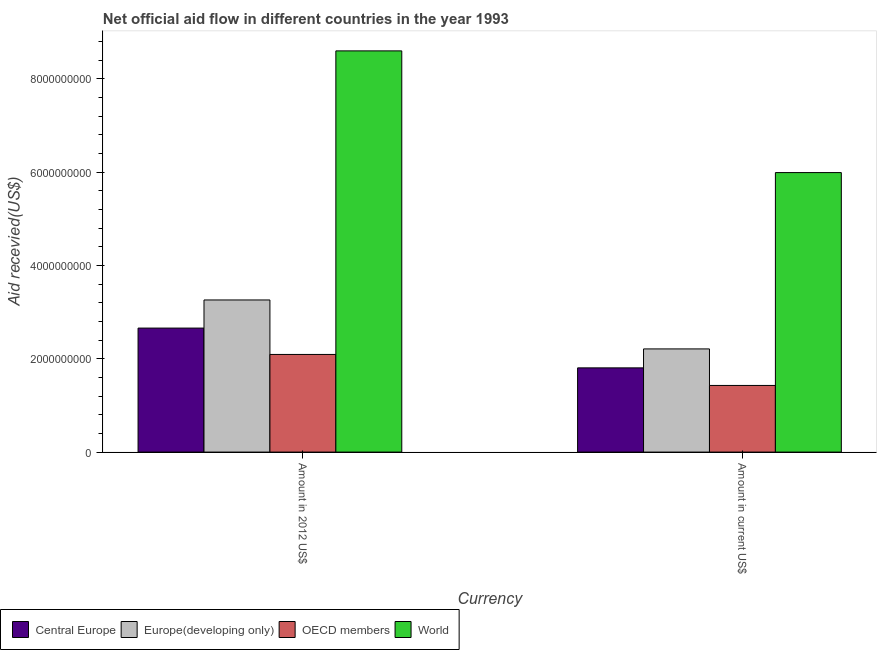How many different coloured bars are there?
Your response must be concise. 4. How many groups of bars are there?
Provide a short and direct response. 2. Are the number of bars on each tick of the X-axis equal?
Provide a short and direct response. Yes. How many bars are there on the 1st tick from the right?
Provide a short and direct response. 4. What is the label of the 2nd group of bars from the left?
Ensure brevity in your answer.  Amount in current US$. What is the amount of aid received(expressed in us$) in OECD members?
Offer a terse response. 1.43e+09. Across all countries, what is the maximum amount of aid received(expressed in 2012 us$)?
Ensure brevity in your answer.  8.60e+09. Across all countries, what is the minimum amount of aid received(expressed in 2012 us$)?
Keep it short and to the point. 2.09e+09. In which country was the amount of aid received(expressed in us$) maximum?
Make the answer very short. World. In which country was the amount of aid received(expressed in 2012 us$) minimum?
Keep it short and to the point. OECD members. What is the total amount of aid received(expressed in us$) in the graph?
Make the answer very short. 1.14e+1. What is the difference between the amount of aid received(expressed in us$) in OECD members and that in Europe(developing only)?
Offer a very short reply. -7.83e+08. What is the difference between the amount of aid received(expressed in us$) in Central Europe and the amount of aid received(expressed in 2012 us$) in World?
Your answer should be compact. -6.79e+09. What is the average amount of aid received(expressed in us$) per country?
Ensure brevity in your answer.  2.86e+09. What is the difference between the amount of aid received(expressed in 2012 us$) and amount of aid received(expressed in us$) in Central Europe?
Offer a terse response. 8.53e+08. What is the ratio of the amount of aid received(expressed in 2012 us$) in OECD members to that in Central Europe?
Make the answer very short. 0.79. What does the 1st bar from the right in Amount in 2012 US$ represents?
Your answer should be very brief. World. How many countries are there in the graph?
Offer a terse response. 4. What is the difference between two consecutive major ticks on the Y-axis?
Your response must be concise. 2.00e+09. Are the values on the major ticks of Y-axis written in scientific E-notation?
Keep it short and to the point. No. How many legend labels are there?
Make the answer very short. 4. How are the legend labels stacked?
Keep it short and to the point. Horizontal. What is the title of the graph?
Your response must be concise. Net official aid flow in different countries in the year 1993. What is the label or title of the X-axis?
Give a very brief answer. Currency. What is the label or title of the Y-axis?
Keep it short and to the point. Aid recevied(US$). What is the Aid recevied(US$) of Central Europe in Amount in 2012 US$?
Offer a terse response. 2.66e+09. What is the Aid recevied(US$) of Europe(developing only) in Amount in 2012 US$?
Provide a short and direct response. 3.26e+09. What is the Aid recevied(US$) in OECD members in Amount in 2012 US$?
Make the answer very short. 2.09e+09. What is the Aid recevied(US$) of World in Amount in 2012 US$?
Keep it short and to the point. 8.60e+09. What is the Aid recevied(US$) of Central Europe in Amount in current US$?
Make the answer very short. 1.80e+09. What is the Aid recevied(US$) in Europe(developing only) in Amount in current US$?
Your answer should be very brief. 2.21e+09. What is the Aid recevied(US$) of OECD members in Amount in current US$?
Your answer should be very brief. 1.43e+09. What is the Aid recevied(US$) in World in Amount in current US$?
Your answer should be compact. 5.99e+09. Across all Currency, what is the maximum Aid recevied(US$) in Central Europe?
Offer a very short reply. 2.66e+09. Across all Currency, what is the maximum Aid recevied(US$) in Europe(developing only)?
Give a very brief answer. 3.26e+09. Across all Currency, what is the maximum Aid recevied(US$) of OECD members?
Offer a terse response. 2.09e+09. Across all Currency, what is the maximum Aid recevied(US$) in World?
Ensure brevity in your answer.  8.60e+09. Across all Currency, what is the minimum Aid recevied(US$) in Central Europe?
Provide a short and direct response. 1.80e+09. Across all Currency, what is the minimum Aid recevied(US$) of Europe(developing only)?
Ensure brevity in your answer.  2.21e+09. Across all Currency, what is the minimum Aid recevied(US$) of OECD members?
Give a very brief answer. 1.43e+09. Across all Currency, what is the minimum Aid recevied(US$) of World?
Ensure brevity in your answer.  5.99e+09. What is the total Aid recevied(US$) in Central Europe in the graph?
Provide a succinct answer. 4.46e+09. What is the total Aid recevied(US$) of Europe(developing only) in the graph?
Offer a terse response. 5.47e+09. What is the total Aid recevied(US$) of OECD members in the graph?
Offer a terse response. 3.52e+09. What is the total Aid recevied(US$) of World in the graph?
Your answer should be compact. 1.46e+1. What is the difference between the Aid recevied(US$) of Central Europe in Amount in 2012 US$ and that in Amount in current US$?
Provide a short and direct response. 8.53e+08. What is the difference between the Aid recevied(US$) in Europe(developing only) in Amount in 2012 US$ and that in Amount in current US$?
Provide a succinct answer. 1.05e+09. What is the difference between the Aid recevied(US$) of OECD members in Amount in 2012 US$ and that in Amount in current US$?
Offer a terse response. 6.65e+08. What is the difference between the Aid recevied(US$) of World in Amount in 2012 US$ and that in Amount in current US$?
Offer a terse response. 2.61e+09. What is the difference between the Aid recevied(US$) of Central Europe in Amount in 2012 US$ and the Aid recevied(US$) of Europe(developing only) in Amount in current US$?
Give a very brief answer. 4.46e+08. What is the difference between the Aid recevied(US$) of Central Europe in Amount in 2012 US$ and the Aid recevied(US$) of OECD members in Amount in current US$?
Your answer should be compact. 1.23e+09. What is the difference between the Aid recevied(US$) in Central Europe in Amount in 2012 US$ and the Aid recevied(US$) in World in Amount in current US$?
Keep it short and to the point. -3.33e+09. What is the difference between the Aid recevied(US$) of Europe(developing only) in Amount in 2012 US$ and the Aid recevied(US$) of OECD members in Amount in current US$?
Your answer should be compact. 1.83e+09. What is the difference between the Aid recevied(US$) in Europe(developing only) in Amount in 2012 US$ and the Aid recevied(US$) in World in Amount in current US$?
Provide a succinct answer. -2.73e+09. What is the difference between the Aid recevied(US$) of OECD members in Amount in 2012 US$ and the Aid recevied(US$) of World in Amount in current US$?
Provide a succinct answer. -3.90e+09. What is the average Aid recevied(US$) in Central Europe per Currency?
Provide a short and direct response. 2.23e+09. What is the average Aid recevied(US$) of Europe(developing only) per Currency?
Your answer should be very brief. 2.74e+09. What is the average Aid recevied(US$) of OECD members per Currency?
Offer a very short reply. 1.76e+09. What is the average Aid recevied(US$) in World per Currency?
Provide a succinct answer. 7.29e+09. What is the difference between the Aid recevied(US$) of Central Europe and Aid recevied(US$) of Europe(developing only) in Amount in 2012 US$?
Make the answer very short. -6.03e+08. What is the difference between the Aid recevied(US$) in Central Europe and Aid recevied(US$) in OECD members in Amount in 2012 US$?
Offer a very short reply. 5.65e+08. What is the difference between the Aid recevied(US$) in Central Europe and Aid recevied(US$) in World in Amount in 2012 US$?
Give a very brief answer. -5.94e+09. What is the difference between the Aid recevied(US$) of Europe(developing only) and Aid recevied(US$) of OECD members in Amount in 2012 US$?
Make the answer very short. 1.17e+09. What is the difference between the Aid recevied(US$) in Europe(developing only) and Aid recevied(US$) in World in Amount in 2012 US$?
Your answer should be very brief. -5.34e+09. What is the difference between the Aid recevied(US$) in OECD members and Aid recevied(US$) in World in Amount in 2012 US$?
Offer a very short reply. -6.50e+09. What is the difference between the Aid recevied(US$) of Central Europe and Aid recevied(US$) of Europe(developing only) in Amount in current US$?
Provide a succinct answer. -4.06e+08. What is the difference between the Aid recevied(US$) of Central Europe and Aid recevied(US$) of OECD members in Amount in current US$?
Offer a terse response. 3.77e+08. What is the difference between the Aid recevied(US$) of Central Europe and Aid recevied(US$) of World in Amount in current US$?
Ensure brevity in your answer.  -4.18e+09. What is the difference between the Aid recevied(US$) of Europe(developing only) and Aid recevied(US$) of OECD members in Amount in current US$?
Give a very brief answer. 7.83e+08. What is the difference between the Aid recevied(US$) in Europe(developing only) and Aid recevied(US$) in World in Amount in current US$?
Offer a very short reply. -3.78e+09. What is the difference between the Aid recevied(US$) in OECD members and Aid recevied(US$) in World in Amount in current US$?
Your answer should be compact. -4.56e+09. What is the ratio of the Aid recevied(US$) in Central Europe in Amount in 2012 US$ to that in Amount in current US$?
Your answer should be compact. 1.47. What is the ratio of the Aid recevied(US$) of Europe(developing only) in Amount in 2012 US$ to that in Amount in current US$?
Your answer should be very brief. 1.47. What is the ratio of the Aid recevied(US$) in OECD members in Amount in 2012 US$ to that in Amount in current US$?
Give a very brief answer. 1.47. What is the ratio of the Aid recevied(US$) of World in Amount in 2012 US$ to that in Amount in current US$?
Provide a succinct answer. 1.44. What is the difference between the highest and the second highest Aid recevied(US$) of Central Europe?
Provide a short and direct response. 8.53e+08. What is the difference between the highest and the second highest Aid recevied(US$) in Europe(developing only)?
Provide a short and direct response. 1.05e+09. What is the difference between the highest and the second highest Aid recevied(US$) of OECD members?
Your answer should be very brief. 6.65e+08. What is the difference between the highest and the second highest Aid recevied(US$) of World?
Make the answer very short. 2.61e+09. What is the difference between the highest and the lowest Aid recevied(US$) of Central Europe?
Offer a very short reply. 8.53e+08. What is the difference between the highest and the lowest Aid recevied(US$) in Europe(developing only)?
Your response must be concise. 1.05e+09. What is the difference between the highest and the lowest Aid recevied(US$) in OECD members?
Provide a short and direct response. 6.65e+08. What is the difference between the highest and the lowest Aid recevied(US$) in World?
Give a very brief answer. 2.61e+09. 